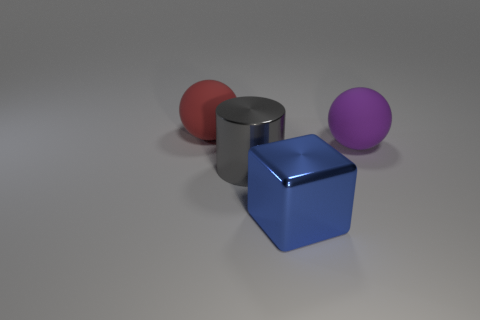Is there anything else that has the same material as the purple sphere?
Make the answer very short. Yes. There is a red thing that is the same shape as the purple thing; what material is it?
Your response must be concise. Rubber. How many cubes are large purple rubber objects or small yellow shiny things?
Provide a short and direct response. 0. How many other large purple things have the same material as the big purple thing?
Your response must be concise. 0. Do the thing that is right of the blue shiny object and the big block left of the purple object have the same material?
Offer a very short reply. No. There is a big sphere in front of the large sphere that is left of the big shiny cylinder; what number of blue shiny cubes are to the right of it?
Your answer should be compact. 0. There is a big matte thing to the left of the thing that is to the right of the big blue block; what is its color?
Offer a terse response. Red. Are there any small blue metal balls?
Ensure brevity in your answer.  No. There is a big object that is left of the shiny block and to the right of the red matte ball; what color is it?
Your response must be concise. Gray. How many other things are the same size as the red thing?
Your response must be concise. 3. 